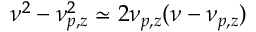Convert formula to latex. <formula><loc_0><loc_0><loc_500><loc_500>\nu ^ { 2 } - \nu _ { p , z } ^ { 2 } \simeq 2 \nu _ { p , z } ( \nu - \nu _ { p , z } )</formula> 